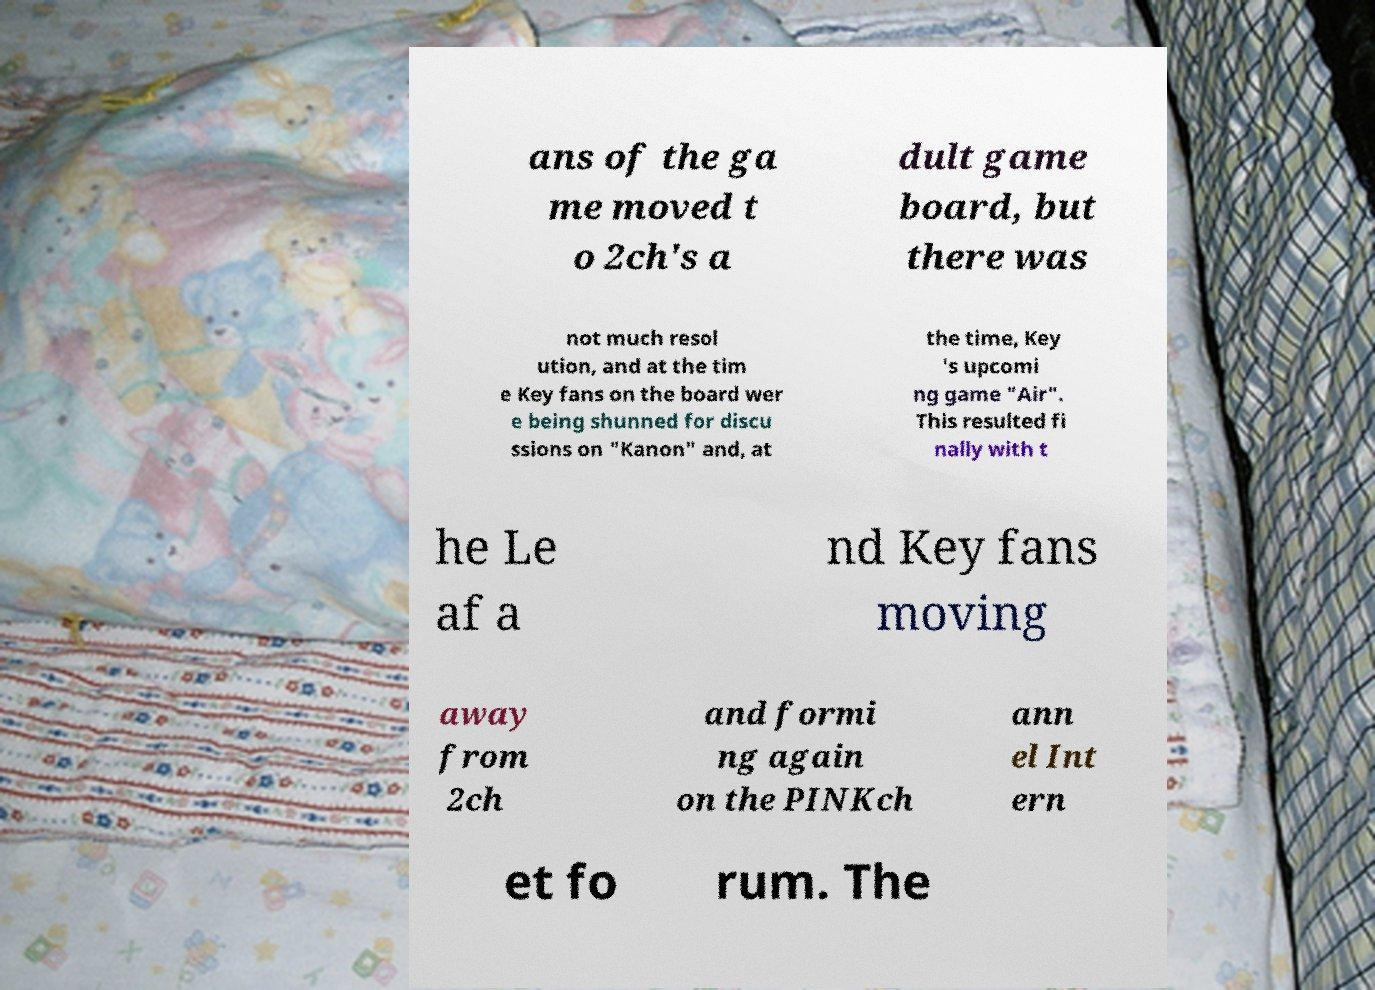I need the written content from this picture converted into text. Can you do that? ans of the ga me moved t o 2ch's a dult game board, but there was not much resol ution, and at the tim e Key fans on the board wer e being shunned for discu ssions on "Kanon" and, at the time, Key 's upcomi ng game "Air". This resulted fi nally with t he Le af a nd Key fans moving away from 2ch and formi ng again on the PINKch ann el Int ern et fo rum. The 